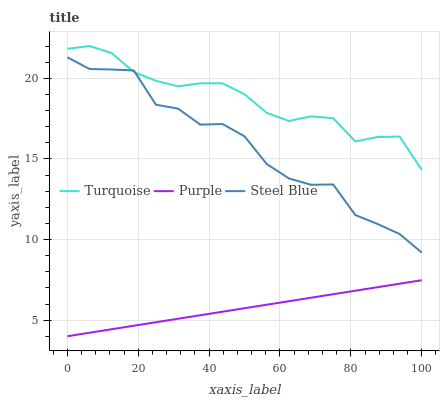Does Purple have the minimum area under the curve?
Answer yes or no. Yes. Does Turquoise have the maximum area under the curve?
Answer yes or no. Yes. Does Steel Blue have the minimum area under the curve?
Answer yes or no. No. Does Steel Blue have the maximum area under the curve?
Answer yes or no. No. Is Purple the smoothest?
Answer yes or no. Yes. Is Steel Blue the roughest?
Answer yes or no. Yes. Is Turquoise the smoothest?
Answer yes or no. No. Is Turquoise the roughest?
Answer yes or no. No. Does Steel Blue have the lowest value?
Answer yes or no. No. Does Turquoise have the highest value?
Answer yes or no. Yes. Does Steel Blue have the highest value?
Answer yes or no. No. Is Purple less than Turquoise?
Answer yes or no. Yes. Is Turquoise greater than Purple?
Answer yes or no. Yes. Does Steel Blue intersect Turquoise?
Answer yes or no. Yes. Is Steel Blue less than Turquoise?
Answer yes or no. No. Is Steel Blue greater than Turquoise?
Answer yes or no. No. Does Purple intersect Turquoise?
Answer yes or no. No. 